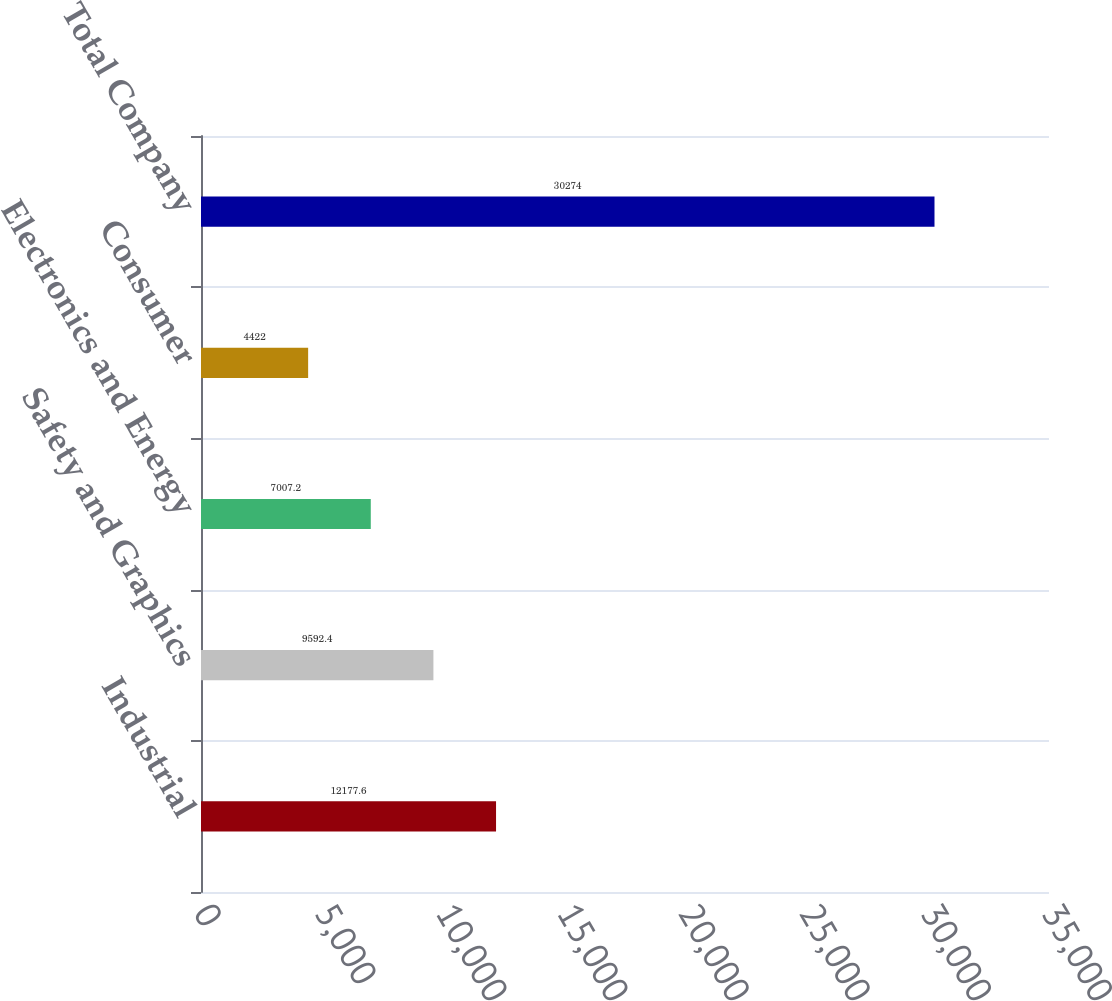<chart> <loc_0><loc_0><loc_500><loc_500><bar_chart><fcel>Industrial<fcel>Safety and Graphics<fcel>Electronics and Energy<fcel>Consumer<fcel>Total Company<nl><fcel>12177.6<fcel>9592.4<fcel>7007.2<fcel>4422<fcel>30274<nl></chart> 